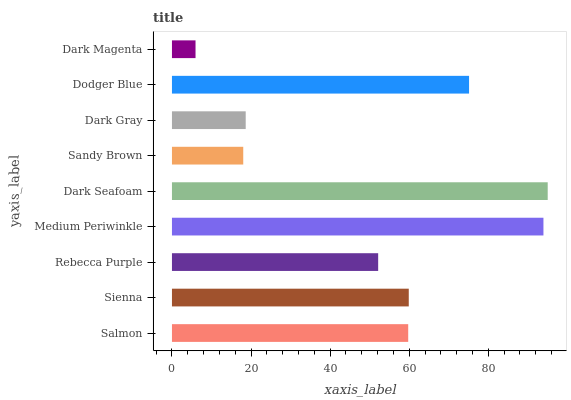Is Dark Magenta the minimum?
Answer yes or no. Yes. Is Dark Seafoam the maximum?
Answer yes or no. Yes. Is Sienna the minimum?
Answer yes or no. No. Is Sienna the maximum?
Answer yes or no. No. Is Sienna greater than Salmon?
Answer yes or no. Yes. Is Salmon less than Sienna?
Answer yes or no. Yes. Is Salmon greater than Sienna?
Answer yes or no. No. Is Sienna less than Salmon?
Answer yes or no. No. Is Salmon the high median?
Answer yes or no. Yes. Is Salmon the low median?
Answer yes or no. Yes. Is Sienna the high median?
Answer yes or no. No. Is Medium Periwinkle the low median?
Answer yes or no. No. 